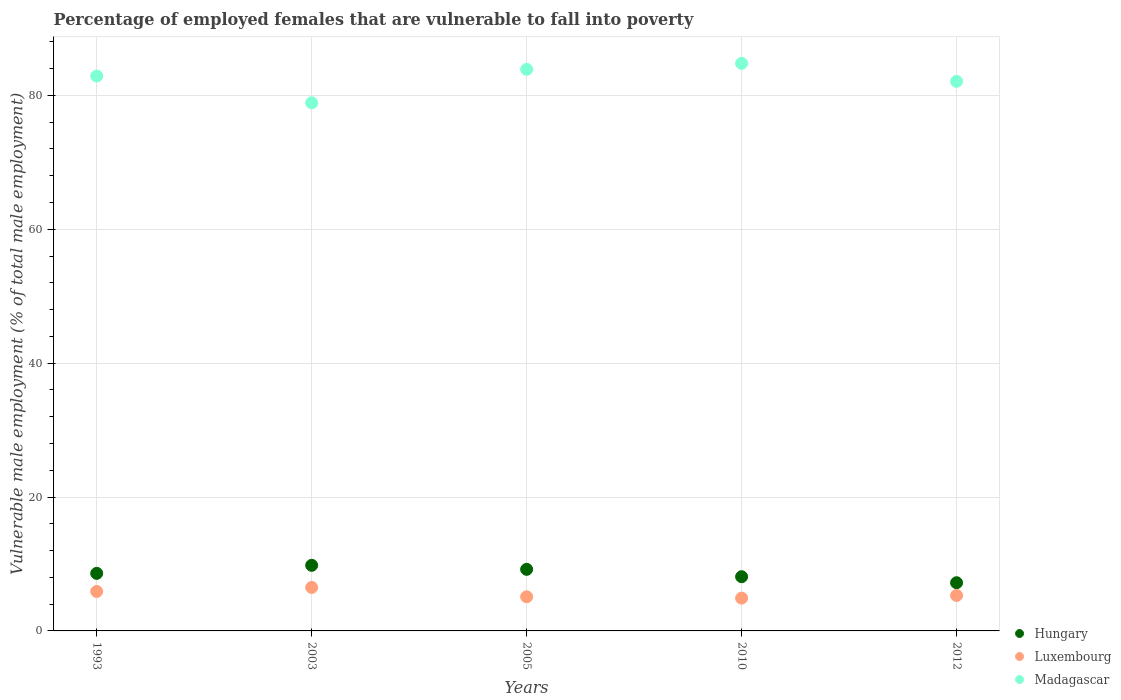Is the number of dotlines equal to the number of legend labels?
Provide a succinct answer. Yes. What is the percentage of employed females who are vulnerable to fall into poverty in Luxembourg in 2012?
Your answer should be very brief. 5.3. Across all years, what is the maximum percentage of employed females who are vulnerable to fall into poverty in Luxembourg?
Ensure brevity in your answer.  6.5. Across all years, what is the minimum percentage of employed females who are vulnerable to fall into poverty in Madagascar?
Make the answer very short. 78.9. In which year was the percentage of employed females who are vulnerable to fall into poverty in Hungary maximum?
Offer a terse response. 2003. What is the total percentage of employed females who are vulnerable to fall into poverty in Hungary in the graph?
Your answer should be very brief. 42.9. What is the difference between the percentage of employed females who are vulnerable to fall into poverty in Luxembourg in 2003 and that in 2010?
Your answer should be compact. 1.6. What is the difference between the percentage of employed females who are vulnerable to fall into poverty in Hungary in 2005 and the percentage of employed females who are vulnerable to fall into poverty in Madagascar in 2010?
Your response must be concise. -75.6. What is the average percentage of employed females who are vulnerable to fall into poverty in Hungary per year?
Offer a very short reply. 8.58. In the year 2003, what is the difference between the percentage of employed females who are vulnerable to fall into poverty in Madagascar and percentage of employed females who are vulnerable to fall into poverty in Luxembourg?
Make the answer very short. 72.4. In how many years, is the percentage of employed females who are vulnerable to fall into poverty in Madagascar greater than 84 %?
Give a very brief answer. 1. What is the ratio of the percentage of employed females who are vulnerable to fall into poverty in Hungary in 1993 to that in 2003?
Your response must be concise. 0.88. What is the difference between the highest and the second highest percentage of employed females who are vulnerable to fall into poverty in Luxembourg?
Offer a very short reply. 0.6. What is the difference between the highest and the lowest percentage of employed females who are vulnerable to fall into poverty in Luxembourg?
Offer a terse response. 1.6. Is the sum of the percentage of employed females who are vulnerable to fall into poverty in Madagascar in 1993 and 2010 greater than the maximum percentage of employed females who are vulnerable to fall into poverty in Hungary across all years?
Ensure brevity in your answer.  Yes. Is it the case that in every year, the sum of the percentage of employed females who are vulnerable to fall into poverty in Luxembourg and percentage of employed females who are vulnerable to fall into poverty in Hungary  is greater than the percentage of employed females who are vulnerable to fall into poverty in Madagascar?
Offer a terse response. No. Is the percentage of employed females who are vulnerable to fall into poverty in Luxembourg strictly greater than the percentage of employed females who are vulnerable to fall into poverty in Hungary over the years?
Your answer should be compact. No. Is the percentage of employed females who are vulnerable to fall into poverty in Hungary strictly less than the percentage of employed females who are vulnerable to fall into poverty in Madagascar over the years?
Make the answer very short. Yes. What is the difference between two consecutive major ticks on the Y-axis?
Provide a short and direct response. 20. Are the values on the major ticks of Y-axis written in scientific E-notation?
Provide a short and direct response. No. Does the graph contain any zero values?
Provide a succinct answer. No. What is the title of the graph?
Give a very brief answer. Percentage of employed females that are vulnerable to fall into poverty. What is the label or title of the Y-axis?
Ensure brevity in your answer.  Vulnerable male employment (% of total male employment). What is the Vulnerable male employment (% of total male employment) of Hungary in 1993?
Keep it short and to the point. 8.6. What is the Vulnerable male employment (% of total male employment) of Luxembourg in 1993?
Your answer should be very brief. 5.9. What is the Vulnerable male employment (% of total male employment) in Madagascar in 1993?
Your answer should be compact. 82.9. What is the Vulnerable male employment (% of total male employment) in Hungary in 2003?
Ensure brevity in your answer.  9.8. What is the Vulnerable male employment (% of total male employment) of Madagascar in 2003?
Ensure brevity in your answer.  78.9. What is the Vulnerable male employment (% of total male employment) of Hungary in 2005?
Offer a very short reply. 9.2. What is the Vulnerable male employment (% of total male employment) of Luxembourg in 2005?
Offer a very short reply. 5.1. What is the Vulnerable male employment (% of total male employment) of Madagascar in 2005?
Give a very brief answer. 83.9. What is the Vulnerable male employment (% of total male employment) in Hungary in 2010?
Offer a very short reply. 8.1. What is the Vulnerable male employment (% of total male employment) in Luxembourg in 2010?
Offer a terse response. 4.9. What is the Vulnerable male employment (% of total male employment) of Madagascar in 2010?
Your answer should be very brief. 84.8. What is the Vulnerable male employment (% of total male employment) in Hungary in 2012?
Ensure brevity in your answer.  7.2. What is the Vulnerable male employment (% of total male employment) in Luxembourg in 2012?
Make the answer very short. 5.3. What is the Vulnerable male employment (% of total male employment) of Madagascar in 2012?
Your response must be concise. 82.1. Across all years, what is the maximum Vulnerable male employment (% of total male employment) in Hungary?
Offer a terse response. 9.8. Across all years, what is the maximum Vulnerable male employment (% of total male employment) in Madagascar?
Your answer should be very brief. 84.8. Across all years, what is the minimum Vulnerable male employment (% of total male employment) of Hungary?
Provide a short and direct response. 7.2. Across all years, what is the minimum Vulnerable male employment (% of total male employment) of Luxembourg?
Offer a very short reply. 4.9. Across all years, what is the minimum Vulnerable male employment (% of total male employment) of Madagascar?
Your answer should be compact. 78.9. What is the total Vulnerable male employment (% of total male employment) of Hungary in the graph?
Provide a succinct answer. 42.9. What is the total Vulnerable male employment (% of total male employment) in Luxembourg in the graph?
Give a very brief answer. 27.7. What is the total Vulnerable male employment (% of total male employment) of Madagascar in the graph?
Make the answer very short. 412.6. What is the difference between the Vulnerable male employment (% of total male employment) of Hungary in 1993 and that in 2005?
Provide a succinct answer. -0.6. What is the difference between the Vulnerable male employment (% of total male employment) in Madagascar in 1993 and that in 2005?
Provide a short and direct response. -1. What is the difference between the Vulnerable male employment (% of total male employment) in Hungary in 1993 and that in 2010?
Provide a short and direct response. 0.5. What is the difference between the Vulnerable male employment (% of total male employment) of Luxembourg in 1993 and that in 2010?
Give a very brief answer. 1. What is the difference between the Vulnerable male employment (% of total male employment) of Madagascar in 1993 and that in 2010?
Offer a very short reply. -1.9. What is the difference between the Vulnerable male employment (% of total male employment) in Madagascar in 1993 and that in 2012?
Provide a succinct answer. 0.8. What is the difference between the Vulnerable male employment (% of total male employment) in Madagascar in 2003 and that in 2005?
Offer a very short reply. -5. What is the difference between the Vulnerable male employment (% of total male employment) of Luxembourg in 2003 and that in 2010?
Offer a very short reply. 1.6. What is the difference between the Vulnerable male employment (% of total male employment) of Hungary in 2003 and that in 2012?
Your answer should be compact. 2.6. What is the difference between the Vulnerable male employment (% of total male employment) of Madagascar in 2003 and that in 2012?
Your answer should be very brief. -3.2. What is the difference between the Vulnerable male employment (% of total male employment) of Hungary in 2005 and that in 2010?
Make the answer very short. 1.1. What is the difference between the Vulnerable male employment (% of total male employment) of Madagascar in 2005 and that in 2010?
Keep it short and to the point. -0.9. What is the difference between the Vulnerable male employment (% of total male employment) of Hungary in 2005 and that in 2012?
Offer a terse response. 2. What is the difference between the Vulnerable male employment (% of total male employment) in Madagascar in 2005 and that in 2012?
Provide a succinct answer. 1.8. What is the difference between the Vulnerable male employment (% of total male employment) in Hungary in 2010 and that in 2012?
Offer a very short reply. 0.9. What is the difference between the Vulnerable male employment (% of total male employment) in Madagascar in 2010 and that in 2012?
Your answer should be very brief. 2.7. What is the difference between the Vulnerable male employment (% of total male employment) of Hungary in 1993 and the Vulnerable male employment (% of total male employment) of Madagascar in 2003?
Offer a very short reply. -70.3. What is the difference between the Vulnerable male employment (% of total male employment) in Luxembourg in 1993 and the Vulnerable male employment (% of total male employment) in Madagascar in 2003?
Ensure brevity in your answer.  -73. What is the difference between the Vulnerable male employment (% of total male employment) in Hungary in 1993 and the Vulnerable male employment (% of total male employment) in Madagascar in 2005?
Keep it short and to the point. -75.3. What is the difference between the Vulnerable male employment (% of total male employment) in Luxembourg in 1993 and the Vulnerable male employment (% of total male employment) in Madagascar in 2005?
Make the answer very short. -78. What is the difference between the Vulnerable male employment (% of total male employment) in Hungary in 1993 and the Vulnerable male employment (% of total male employment) in Luxembourg in 2010?
Provide a short and direct response. 3.7. What is the difference between the Vulnerable male employment (% of total male employment) of Hungary in 1993 and the Vulnerable male employment (% of total male employment) of Madagascar in 2010?
Give a very brief answer. -76.2. What is the difference between the Vulnerable male employment (% of total male employment) in Luxembourg in 1993 and the Vulnerable male employment (% of total male employment) in Madagascar in 2010?
Provide a short and direct response. -78.9. What is the difference between the Vulnerable male employment (% of total male employment) in Hungary in 1993 and the Vulnerable male employment (% of total male employment) in Luxembourg in 2012?
Offer a terse response. 3.3. What is the difference between the Vulnerable male employment (% of total male employment) in Hungary in 1993 and the Vulnerable male employment (% of total male employment) in Madagascar in 2012?
Keep it short and to the point. -73.5. What is the difference between the Vulnerable male employment (% of total male employment) in Luxembourg in 1993 and the Vulnerable male employment (% of total male employment) in Madagascar in 2012?
Make the answer very short. -76.2. What is the difference between the Vulnerable male employment (% of total male employment) in Hungary in 2003 and the Vulnerable male employment (% of total male employment) in Luxembourg in 2005?
Offer a very short reply. 4.7. What is the difference between the Vulnerable male employment (% of total male employment) of Hungary in 2003 and the Vulnerable male employment (% of total male employment) of Madagascar in 2005?
Provide a succinct answer. -74.1. What is the difference between the Vulnerable male employment (% of total male employment) in Luxembourg in 2003 and the Vulnerable male employment (% of total male employment) in Madagascar in 2005?
Provide a succinct answer. -77.4. What is the difference between the Vulnerable male employment (% of total male employment) of Hungary in 2003 and the Vulnerable male employment (% of total male employment) of Luxembourg in 2010?
Your answer should be very brief. 4.9. What is the difference between the Vulnerable male employment (% of total male employment) of Hungary in 2003 and the Vulnerable male employment (% of total male employment) of Madagascar in 2010?
Your answer should be very brief. -75. What is the difference between the Vulnerable male employment (% of total male employment) of Luxembourg in 2003 and the Vulnerable male employment (% of total male employment) of Madagascar in 2010?
Provide a succinct answer. -78.3. What is the difference between the Vulnerable male employment (% of total male employment) of Hungary in 2003 and the Vulnerable male employment (% of total male employment) of Madagascar in 2012?
Provide a short and direct response. -72.3. What is the difference between the Vulnerable male employment (% of total male employment) of Luxembourg in 2003 and the Vulnerable male employment (% of total male employment) of Madagascar in 2012?
Make the answer very short. -75.6. What is the difference between the Vulnerable male employment (% of total male employment) of Hungary in 2005 and the Vulnerable male employment (% of total male employment) of Madagascar in 2010?
Keep it short and to the point. -75.6. What is the difference between the Vulnerable male employment (% of total male employment) in Luxembourg in 2005 and the Vulnerable male employment (% of total male employment) in Madagascar in 2010?
Your answer should be very brief. -79.7. What is the difference between the Vulnerable male employment (% of total male employment) in Hungary in 2005 and the Vulnerable male employment (% of total male employment) in Luxembourg in 2012?
Your answer should be compact. 3.9. What is the difference between the Vulnerable male employment (% of total male employment) in Hungary in 2005 and the Vulnerable male employment (% of total male employment) in Madagascar in 2012?
Your response must be concise. -72.9. What is the difference between the Vulnerable male employment (% of total male employment) in Luxembourg in 2005 and the Vulnerable male employment (% of total male employment) in Madagascar in 2012?
Provide a short and direct response. -77. What is the difference between the Vulnerable male employment (% of total male employment) in Hungary in 2010 and the Vulnerable male employment (% of total male employment) in Madagascar in 2012?
Keep it short and to the point. -74. What is the difference between the Vulnerable male employment (% of total male employment) in Luxembourg in 2010 and the Vulnerable male employment (% of total male employment) in Madagascar in 2012?
Make the answer very short. -77.2. What is the average Vulnerable male employment (% of total male employment) in Hungary per year?
Make the answer very short. 8.58. What is the average Vulnerable male employment (% of total male employment) of Luxembourg per year?
Ensure brevity in your answer.  5.54. What is the average Vulnerable male employment (% of total male employment) in Madagascar per year?
Keep it short and to the point. 82.52. In the year 1993, what is the difference between the Vulnerable male employment (% of total male employment) in Hungary and Vulnerable male employment (% of total male employment) in Luxembourg?
Provide a succinct answer. 2.7. In the year 1993, what is the difference between the Vulnerable male employment (% of total male employment) of Hungary and Vulnerable male employment (% of total male employment) of Madagascar?
Give a very brief answer. -74.3. In the year 1993, what is the difference between the Vulnerable male employment (% of total male employment) of Luxembourg and Vulnerable male employment (% of total male employment) of Madagascar?
Provide a short and direct response. -77. In the year 2003, what is the difference between the Vulnerable male employment (% of total male employment) of Hungary and Vulnerable male employment (% of total male employment) of Luxembourg?
Ensure brevity in your answer.  3.3. In the year 2003, what is the difference between the Vulnerable male employment (% of total male employment) in Hungary and Vulnerable male employment (% of total male employment) in Madagascar?
Make the answer very short. -69.1. In the year 2003, what is the difference between the Vulnerable male employment (% of total male employment) in Luxembourg and Vulnerable male employment (% of total male employment) in Madagascar?
Give a very brief answer. -72.4. In the year 2005, what is the difference between the Vulnerable male employment (% of total male employment) of Hungary and Vulnerable male employment (% of total male employment) of Madagascar?
Offer a terse response. -74.7. In the year 2005, what is the difference between the Vulnerable male employment (% of total male employment) in Luxembourg and Vulnerable male employment (% of total male employment) in Madagascar?
Your response must be concise. -78.8. In the year 2010, what is the difference between the Vulnerable male employment (% of total male employment) in Hungary and Vulnerable male employment (% of total male employment) in Madagascar?
Give a very brief answer. -76.7. In the year 2010, what is the difference between the Vulnerable male employment (% of total male employment) of Luxembourg and Vulnerable male employment (% of total male employment) of Madagascar?
Your answer should be very brief. -79.9. In the year 2012, what is the difference between the Vulnerable male employment (% of total male employment) in Hungary and Vulnerable male employment (% of total male employment) in Luxembourg?
Give a very brief answer. 1.9. In the year 2012, what is the difference between the Vulnerable male employment (% of total male employment) in Hungary and Vulnerable male employment (% of total male employment) in Madagascar?
Your response must be concise. -74.9. In the year 2012, what is the difference between the Vulnerable male employment (% of total male employment) in Luxembourg and Vulnerable male employment (% of total male employment) in Madagascar?
Ensure brevity in your answer.  -76.8. What is the ratio of the Vulnerable male employment (% of total male employment) in Hungary in 1993 to that in 2003?
Your response must be concise. 0.88. What is the ratio of the Vulnerable male employment (% of total male employment) in Luxembourg in 1993 to that in 2003?
Keep it short and to the point. 0.91. What is the ratio of the Vulnerable male employment (% of total male employment) of Madagascar in 1993 to that in 2003?
Your answer should be very brief. 1.05. What is the ratio of the Vulnerable male employment (% of total male employment) of Hungary in 1993 to that in 2005?
Give a very brief answer. 0.93. What is the ratio of the Vulnerable male employment (% of total male employment) in Luxembourg in 1993 to that in 2005?
Ensure brevity in your answer.  1.16. What is the ratio of the Vulnerable male employment (% of total male employment) of Hungary in 1993 to that in 2010?
Offer a very short reply. 1.06. What is the ratio of the Vulnerable male employment (% of total male employment) in Luxembourg in 1993 to that in 2010?
Your response must be concise. 1.2. What is the ratio of the Vulnerable male employment (% of total male employment) in Madagascar in 1993 to that in 2010?
Provide a short and direct response. 0.98. What is the ratio of the Vulnerable male employment (% of total male employment) in Hungary in 1993 to that in 2012?
Your answer should be compact. 1.19. What is the ratio of the Vulnerable male employment (% of total male employment) in Luxembourg in 1993 to that in 2012?
Your answer should be compact. 1.11. What is the ratio of the Vulnerable male employment (% of total male employment) in Madagascar in 1993 to that in 2012?
Your answer should be very brief. 1.01. What is the ratio of the Vulnerable male employment (% of total male employment) in Hungary in 2003 to that in 2005?
Offer a very short reply. 1.07. What is the ratio of the Vulnerable male employment (% of total male employment) of Luxembourg in 2003 to that in 2005?
Offer a terse response. 1.27. What is the ratio of the Vulnerable male employment (% of total male employment) of Madagascar in 2003 to that in 2005?
Your answer should be compact. 0.94. What is the ratio of the Vulnerable male employment (% of total male employment) of Hungary in 2003 to that in 2010?
Provide a succinct answer. 1.21. What is the ratio of the Vulnerable male employment (% of total male employment) in Luxembourg in 2003 to that in 2010?
Make the answer very short. 1.33. What is the ratio of the Vulnerable male employment (% of total male employment) in Madagascar in 2003 to that in 2010?
Keep it short and to the point. 0.93. What is the ratio of the Vulnerable male employment (% of total male employment) in Hungary in 2003 to that in 2012?
Offer a very short reply. 1.36. What is the ratio of the Vulnerable male employment (% of total male employment) of Luxembourg in 2003 to that in 2012?
Ensure brevity in your answer.  1.23. What is the ratio of the Vulnerable male employment (% of total male employment) of Madagascar in 2003 to that in 2012?
Make the answer very short. 0.96. What is the ratio of the Vulnerable male employment (% of total male employment) in Hungary in 2005 to that in 2010?
Make the answer very short. 1.14. What is the ratio of the Vulnerable male employment (% of total male employment) of Luxembourg in 2005 to that in 2010?
Your answer should be very brief. 1.04. What is the ratio of the Vulnerable male employment (% of total male employment) in Hungary in 2005 to that in 2012?
Ensure brevity in your answer.  1.28. What is the ratio of the Vulnerable male employment (% of total male employment) in Luxembourg in 2005 to that in 2012?
Provide a short and direct response. 0.96. What is the ratio of the Vulnerable male employment (% of total male employment) in Madagascar in 2005 to that in 2012?
Your answer should be compact. 1.02. What is the ratio of the Vulnerable male employment (% of total male employment) of Hungary in 2010 to that in 2012?
Your answer should be compact. 1.12. What is the ratio of the Vulnerable male employment (% of total male employment) of Luxembourg in 2010 to that in 2012?
Provide a short and direct response. 0.92. What is the ratio of the Vulnerable male employment (% of total male employment) of Madagascar in 2010 to that in 2012?
Offer a terse response. 1.03. What is the difference between the highest and the second highest Vulnerable male employment (% of total male employment) of Hungary?
Your answer should be very brief. 0.6. What is the difference between the highest and the lowest Vulnerable male employment (% of total male employment) in Hungary?
Make the answer very short. 2.6. What is the difference between the highest and the lowest Vulnerable male employment (% of total male employment) of Madagascar?
Make the answer very short. 5.9. 